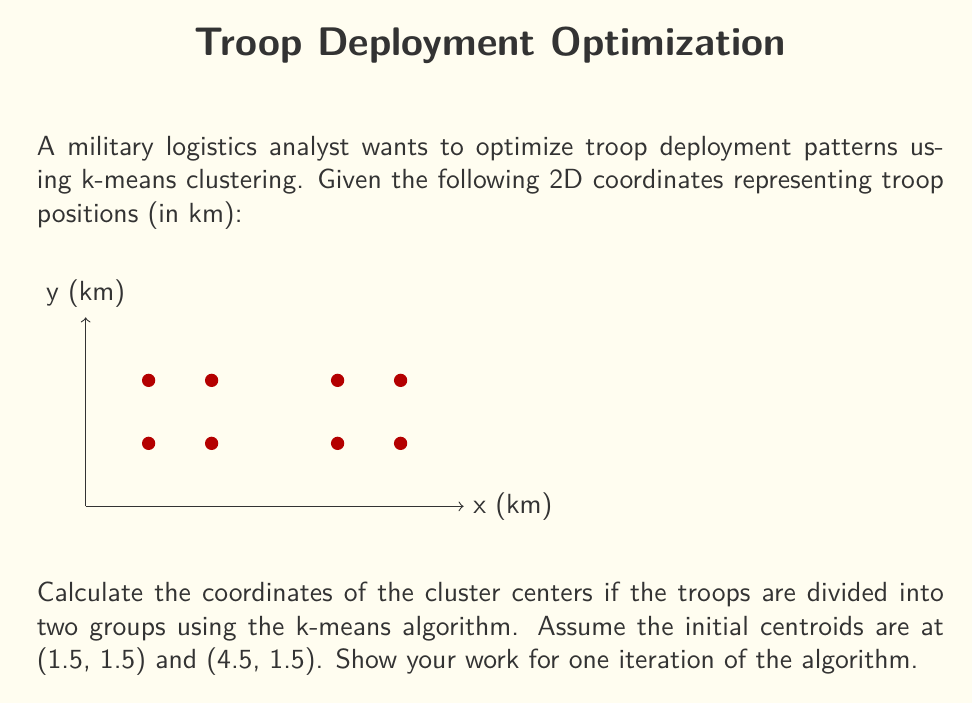Can you answer this question? Let's go through one iteration of the k-means algorithm:

1) Initial centroids:
   $C_1 = (1.5, 1.5)$ and $C_2 = (4.5, 1.5)$

2) Assign each point to the nearest centroid:
   Calculate distances using the Euclidean distance formula:
   $d = \sqrt{(x_2-x_1)^2 + (y_2-y_1)^2}$

   For (1,1): 
   $d_{C_1} = \sqrt{(1.5-1)^2 + (1.5-1)^2} = \sqrt{0.5} \approx 0.71$
   $d_{C_2} = \sqrt{(4.5-1)^2 + (1.5-1)^2} = \sqrt{12.5} \approx 3.54$
   Assign to $C_1$

   Doing this for all points, we get:
   $C_1$: (1,1), (2,1), (1,2), (2,2)
   $C_2$: (4,1), (5,1), (4,2), (5,2)

3) Recalculate centroids:
   For $C_1$:
   $x = (1+2+1+2)/4 = 1.5$
   $y = (1+1+2+2)/4 = 1.5$
   New $C_1 = (1.5, 1.5)$

   For $C_2$:
   $x = (4+5+4+5)/4 = 4.5$
   $y = (1+1+2+2)/4 = 1.5$
   New $C_2 = (4.5, 1.5)$

After one iteration, the centroids remain at their initial positions.
Answer: $C_1 = (1.5, 1.5)$, $C_2 = (4.5, 1.5)$ 